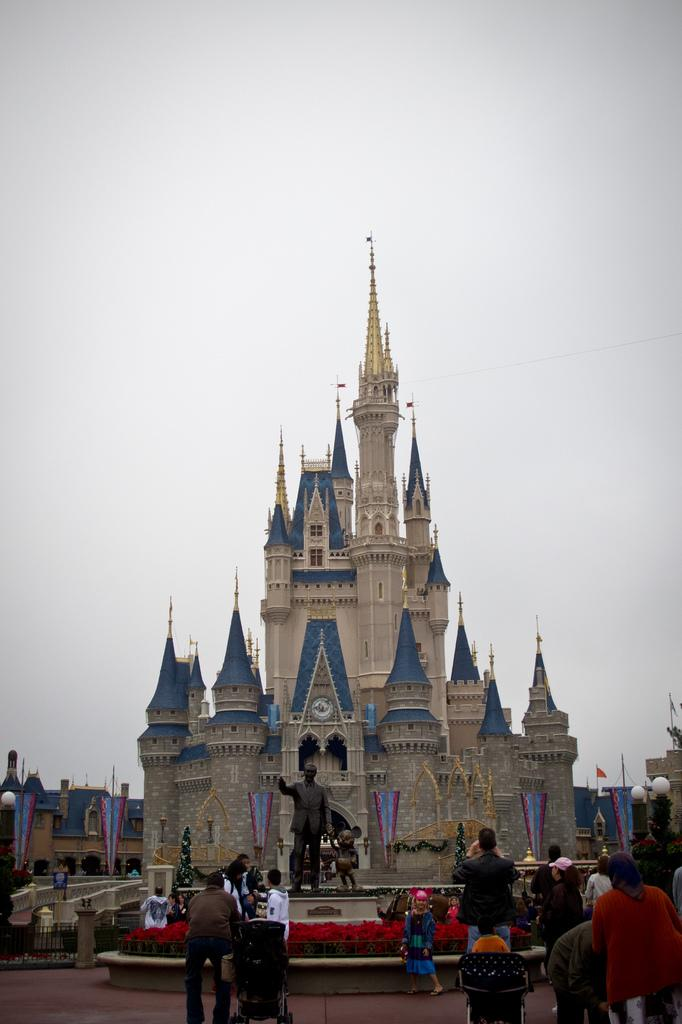How many people are in the image? There is a group of people standing in the image. Can you describe the building in the image? The building in the image has white and blue colors. What is the color of the statue in the image? The statue in the image has a brown color. What is the color of the sky in the image? The sky is visible in the image, with a white color. What type of feast is being prepared in the image? There is no indication of a feast being prepared in the image. 